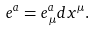<formula> <loc_0><loc_0><loc_500><loc_500>e ^ { a } = e ^ { a } _ { \, \mu } d x ^ { \mu } .</formula> 